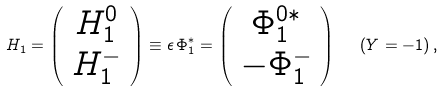Convert formula to latex. <formula><loc_0><loc_0><loc_500><loc_500>H _ { 1 } = \left ( \begin{array} { c } H _ { 1 } ^ { 0 } \\ H _ { 1 } ^ { - } \end{array} \right ) \equiv \epsilon \, \Phi _ { 1 } ^ { * } = \left ( \begin{array} { c } \Phi _ { 1 } ^ { 0 * } \\ - \Phi _ { 1 } ^ { - } \end{array} \right ) \ \ ( Y = - 1 ) \, ,</formula> 